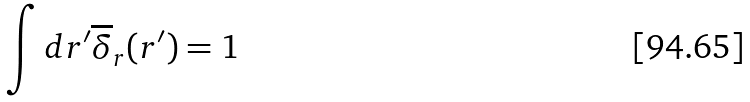<formula> <loc_0><loc_0><loc_500><loc_500>\int d { r } ^ { \prime } \overline { \delta } _ { r } ( { r } ^ { \prime } ) = 1</formula> 